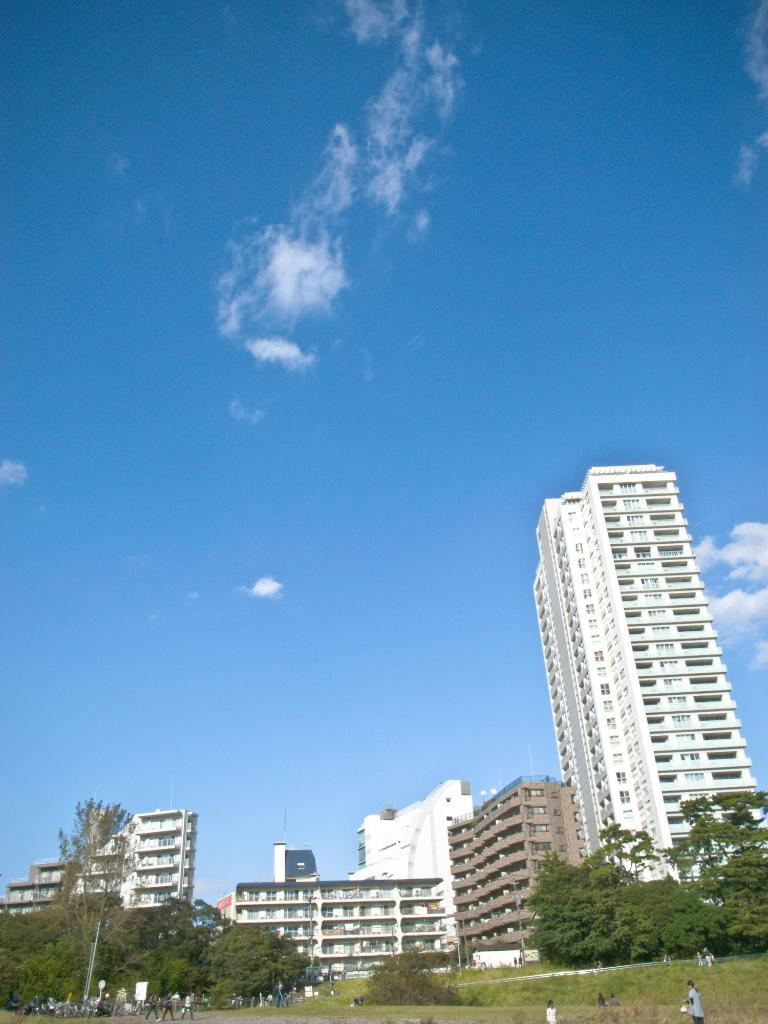What type of structures can be seen in the image? There are buildings in the image. What other natural elements are present in the image? There are trees in the image. What are the people in the image doing? There are people walking and standing in the image. How would you describe the sky in the image? The sky is blue and cloudy in the image. Can you tell me how many tickets are being sold by the vegetable stand in the image? There is no vegetable stand or tickets present in the image. What type of cannon is being fired in the image? There is no cannon present in the image. 